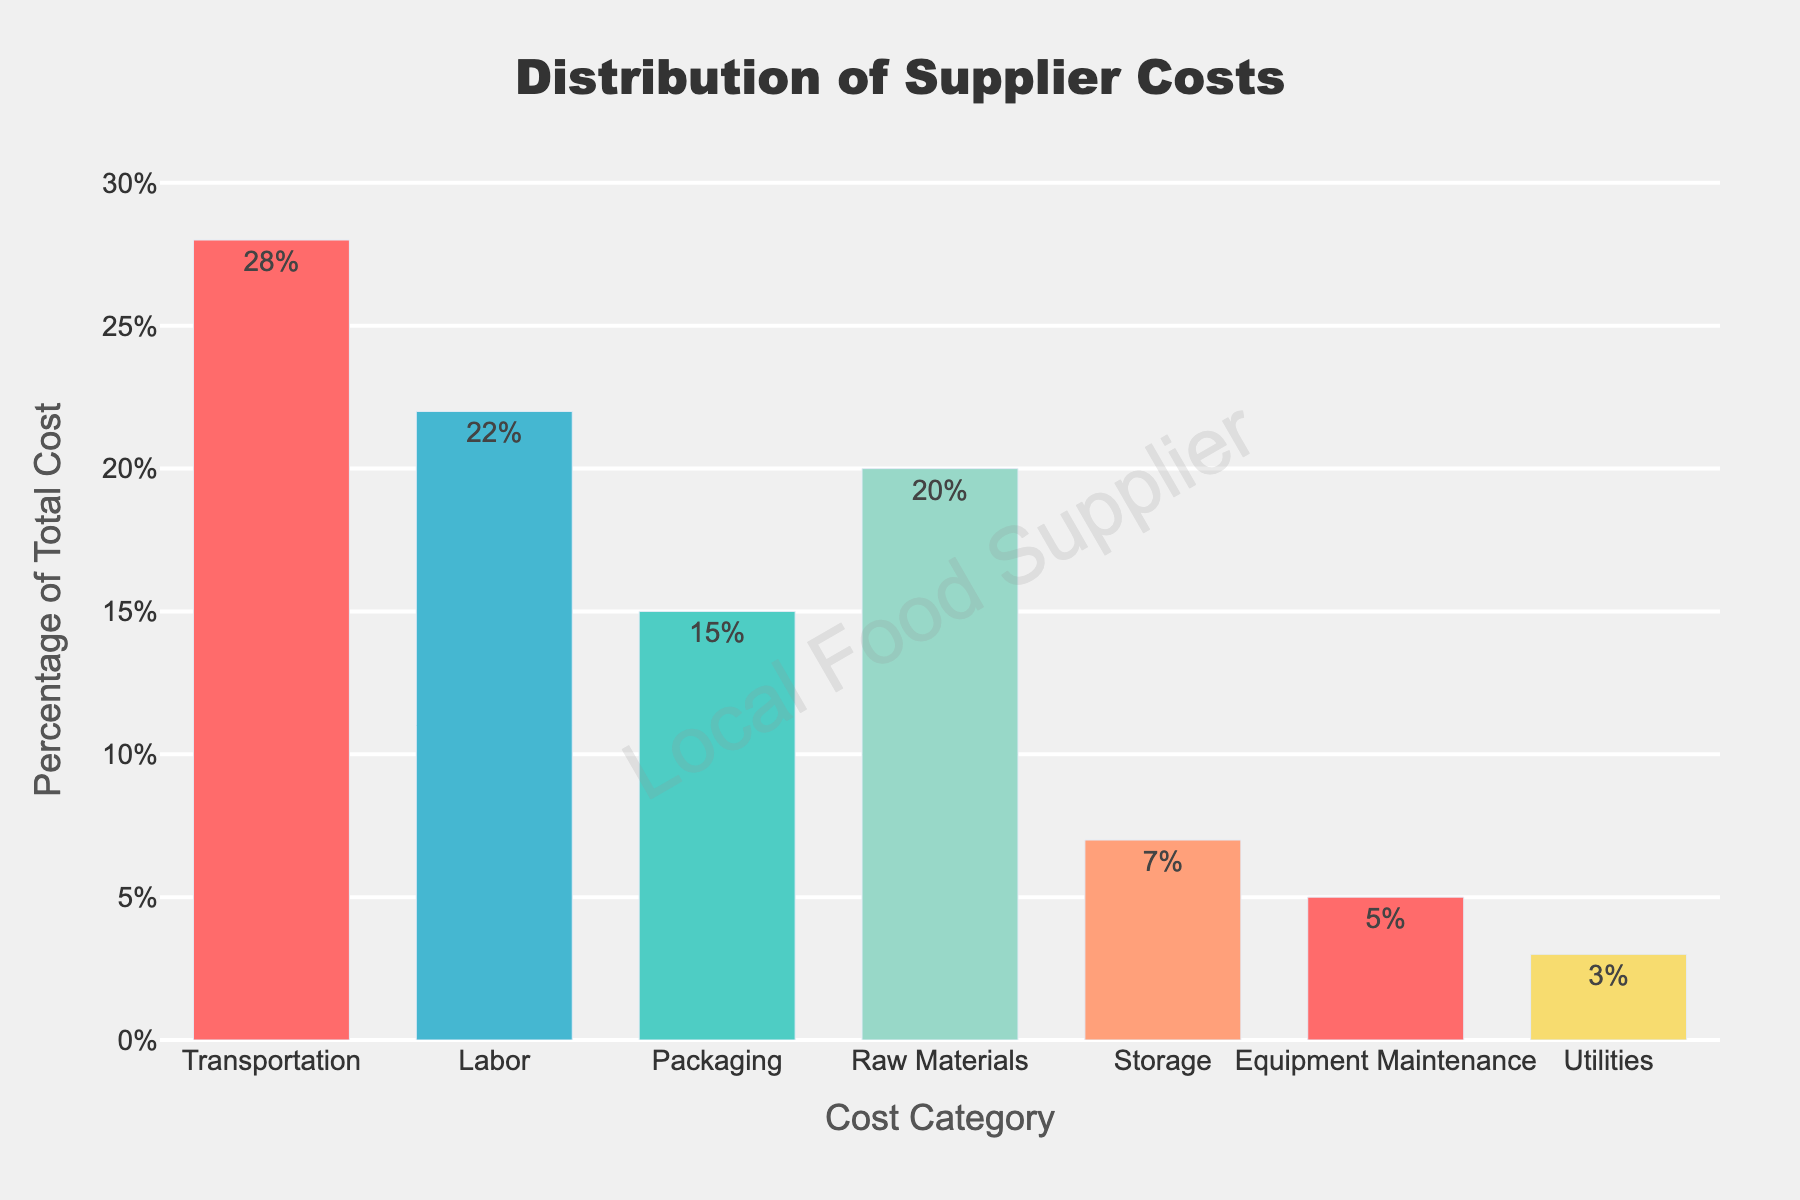what cost category has the highest percentage of the total cost? The bar chart shows different categories with their corresponding percentages. The tallest bar indicates the highest percentage. Here, the "Transportation" category has the tallest bar with 28%.
Answer: Transportation Which two cost categories combined make up the largest portion of the total cost? We look at the top two categories by their bar lengths. "Transportation" is 28% and "Labor" is 22%. Combined, they are 28% + 22% = 50%.
Answer: Transportation and Labor Compare the cost percentages of "Utilities" and "Storage". Which is higher? By comparing the height of the bars for "Utilities" and "Storage", we see that "Storage" is at 7% and "Utilities" is at 3%. Therefore, "Storage" is higher.
Answer: Storage How much more is the percentage of "Raw Materials" than "Packaging"? We subtract the percentage of "Packaging" from "Raw Materials". "Raw Materials" is 20%, and "Packaging" is 15%, so the difference is 20% - 15% = 5%.
Answer: 5% What is the average percentage of total cost across all categories? To find the average, sum all category percentages and then divide by the number of categories. The sum is 28 + 22 + 15 + 20 + 7 + 5 + 3 = 100. There are 7 categories. Thus, the average is 100/7 ≈ 14.29%.
Answer: ≈14.29% What is the least cost-intensive category, and what percentage does it represent? The shortest bar in the chart represents the least cost-intensive category. "Utilities" has the shortest bar with 3%.
Answer: Utilities Which category has a percentage closest to the average percentage of all categories? The average is approximately 14.29%. Comparing this to the categories, "Packaging" is 15%, which is closest to 14.29%.
Answer: Packaging If "Utilities" and "Equipment Maintenance" costs are combined, what percentage of the total cost would they represent? Add the percentages of "Utilities" and "Equipment Maintenance". Utilities is 3% and Equipment Maintenance is 5%. 3% + 5% = 8%.
Answer: 8% How does the percentage of "Labor" compare to "Raw Materials"? By comparing the heights of the bars, "Labor" is 22% and "Raw Materials" is 20%. "Labor" is 2% higher than "Raw Materials".
Answer: Labor is 2% higher If we double the cost of "Storage," how does its new percentage compare to "Labor"? If we double "Storage" (which is 7%), it becomes 14%. "Labor" is 22%. 14% is less than 22%.
Answer: Labor is higher 